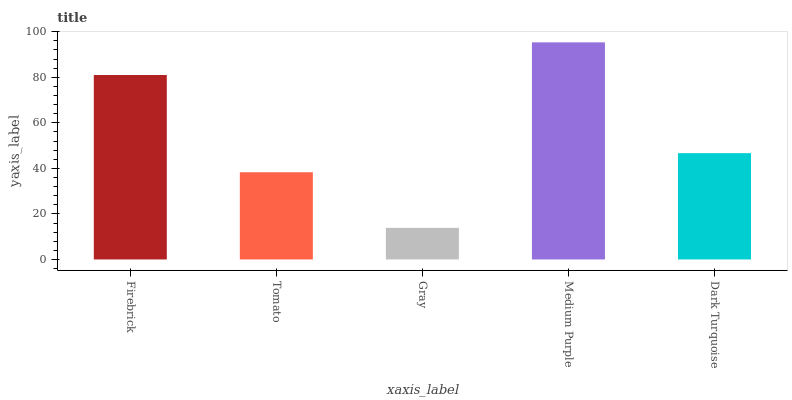Is Gray the minimum?
Answer yes or no. Yes. Is Medium Purple the maximum?
Answer yes or no. Yes. Is Tomato the minimum?
Answer yes or no. No. Is Tomato the maximum?
Answer yes or no. No. Is Firebrick greater than Tomato?
Answer yes or no. Yes. Is Tomato less than Firebrick?
Answer yes or no. Yes. Is Tomato greater than Firebrick?
Answer yes or no. No. Is Firebrick less than Tomato?
Answer yes or no. No. Is Dark Turquoise the high median?
Answer yes or no. Yes. Is Dark Turquoise the low median?
Answer yes or no. Yes. Is Firebrick the high median?
Answer yes or no. No. Is Gray the low median?
Answer yes or no. No. 